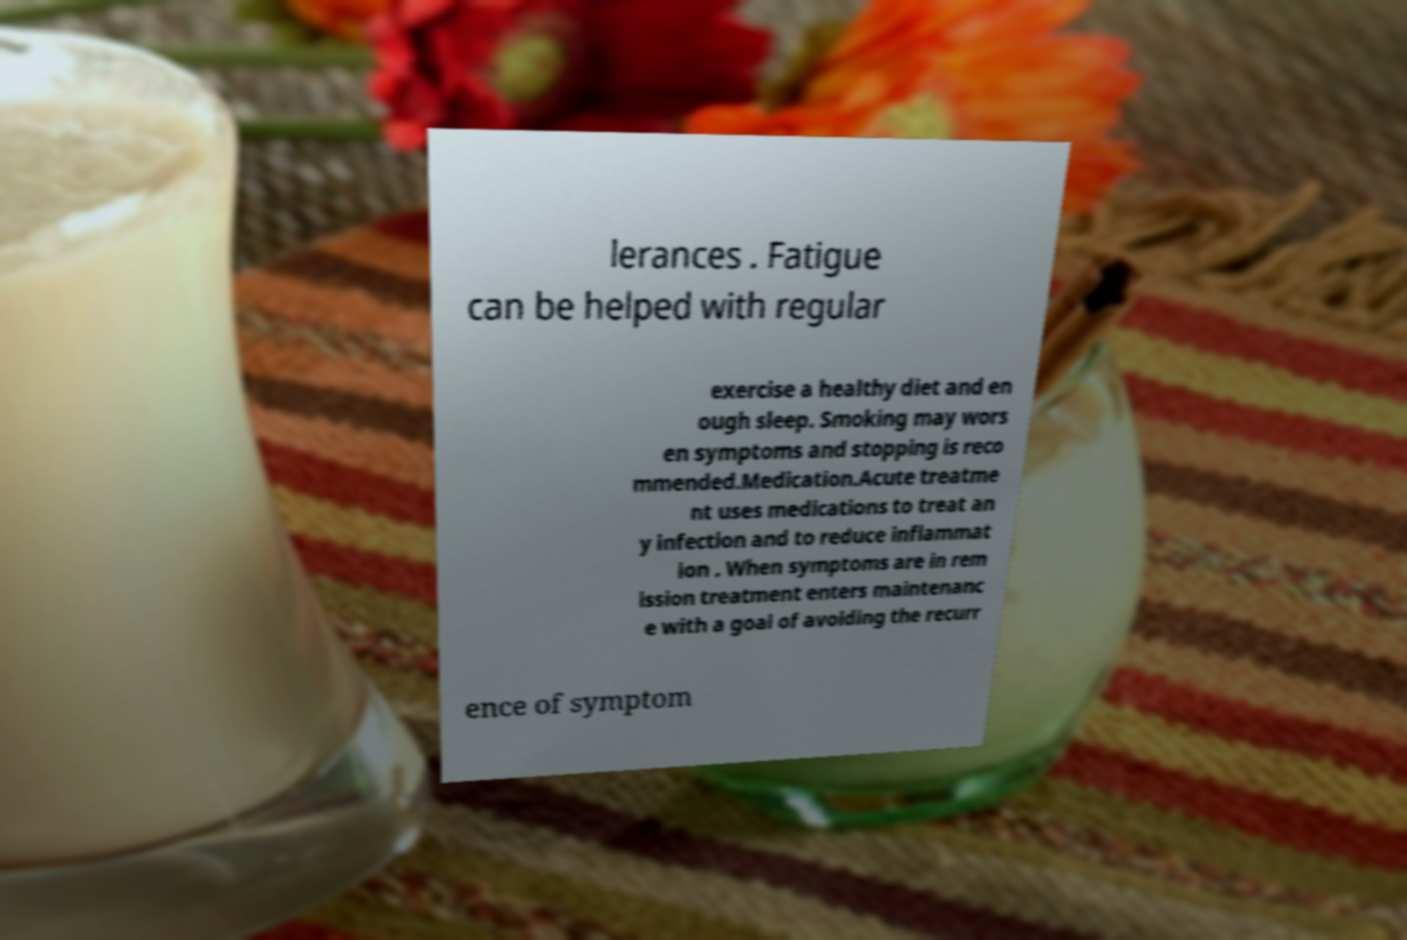Could you extract and type out the text from this image? lerances . Fatigue can be helped with regular exercise a healthy diet and en ough sleep. Smoking may wors en symptoms and stopping is reco mmended.Medication.Acute treatme nt uses medications to treat an y infection and to reduce inflammat ion . When symptoms are in rem ission treatment enters maintenanc e with a goal of avoiding the recurr ence of symptom 